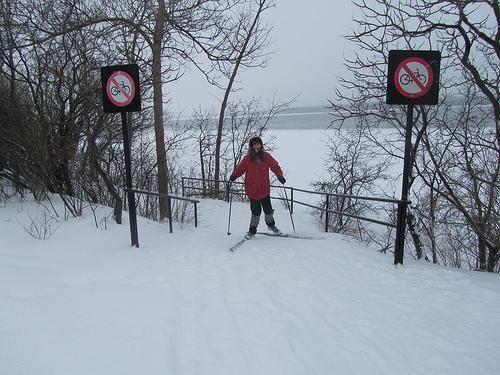How many skis does the person have on?
Give a very brief answer. 2. How many signs are there?
Give a very brief answer. 2. 